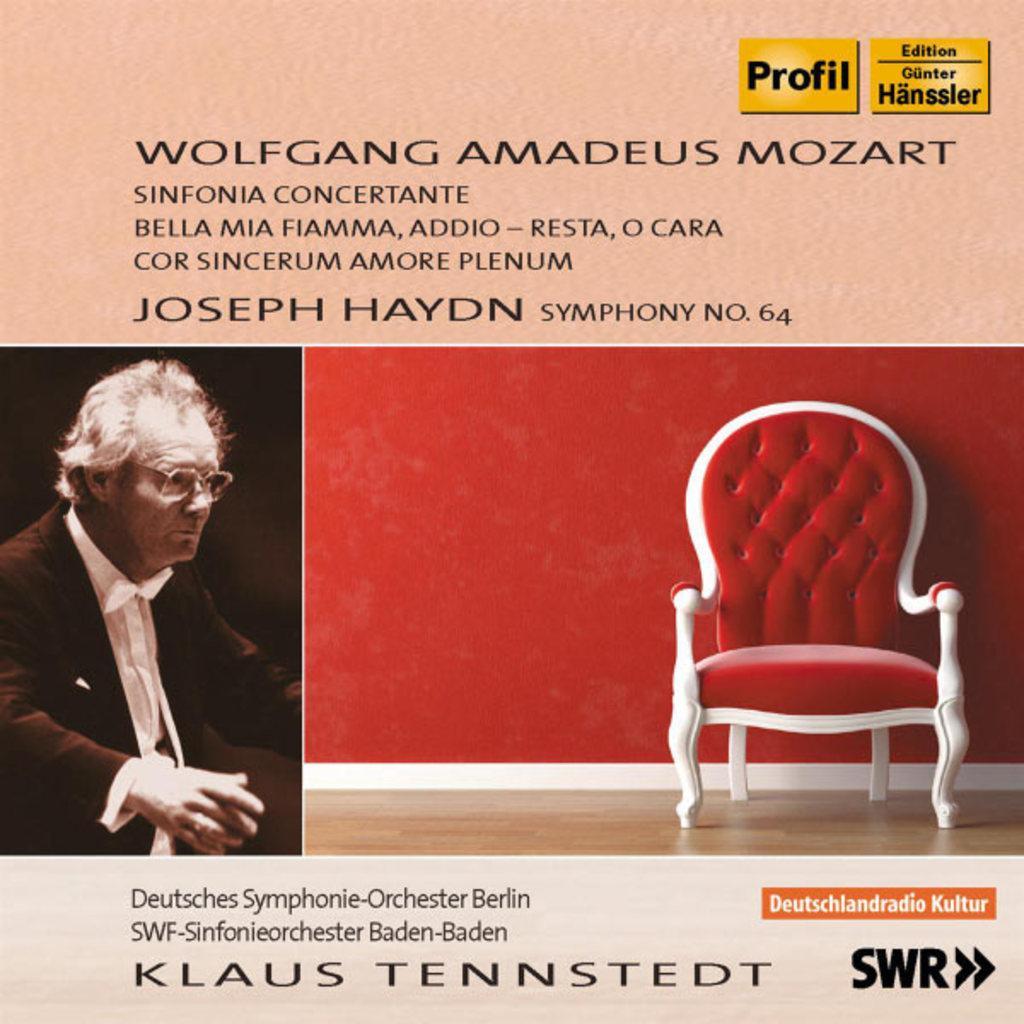How would you summarize this image in a sentence or two? On the left side of the image a man is there. On the right side of the image we can see a chair, wall, floor are present. At the top and bottom of the image we can see some text. 